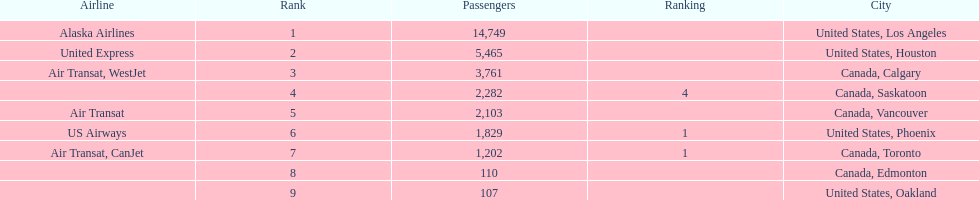Los angeles and what other city had about 19,000 passenger combined Canada, Calgary. 